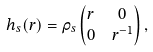<formula> <loc_0><loc_0><loc_500><loc_500>h _ { s } ( r ) & = \rho _ { s } \begin{pmatrix} r & 0 \\ 0 & r ^ { - 1 } \end{pmatrix} ,</formula> 